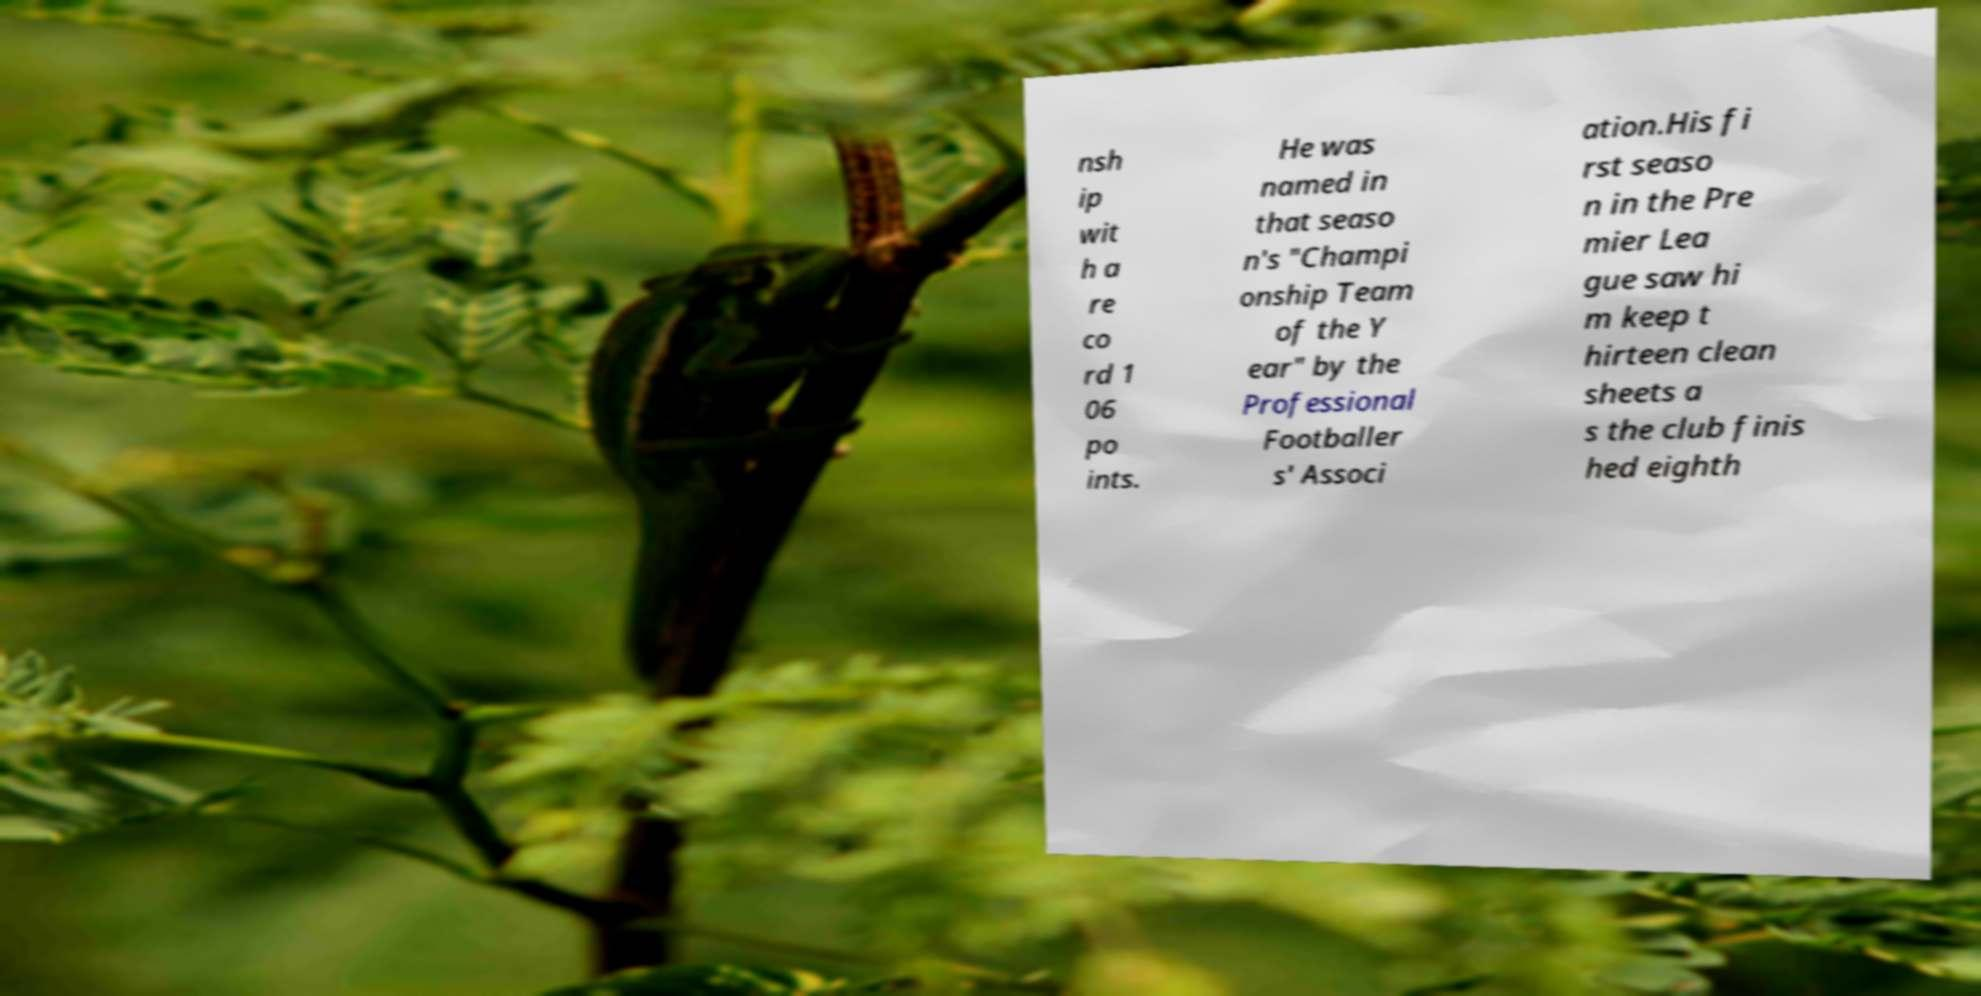For documentation purposes, I need the text within this image transcribed. Could you provide that? nsh ip wit h a re co rd 1 06 po ints. He was named in that seaso n's "Champi onship Team of the Y ear" by the Professional Footballer s' Associ ation.His fi rst seaso n in the Pre mier Lea gue saw hi m keep t hirteen clean sheets a s the club finis hed eighth 